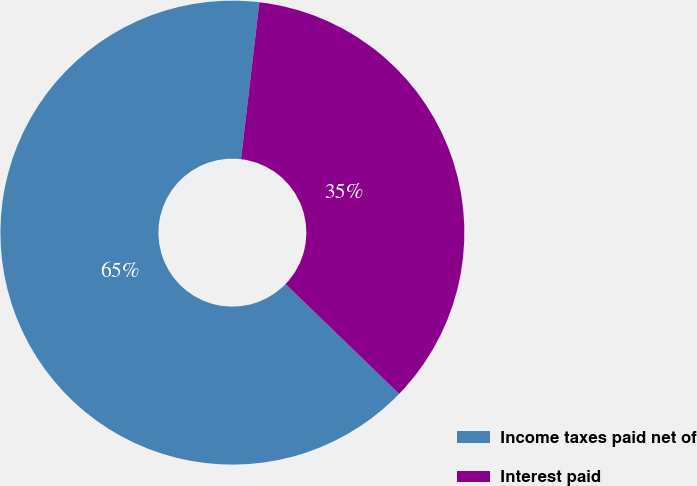Convert chart. <chart><loc_0><loc_0><loc_500><loc_500><pie_chart><fcel>Income taxes paid net of<fcel>Interest paid<nl><fcel>64.62%<fcel>35.38%<nl></chart> 